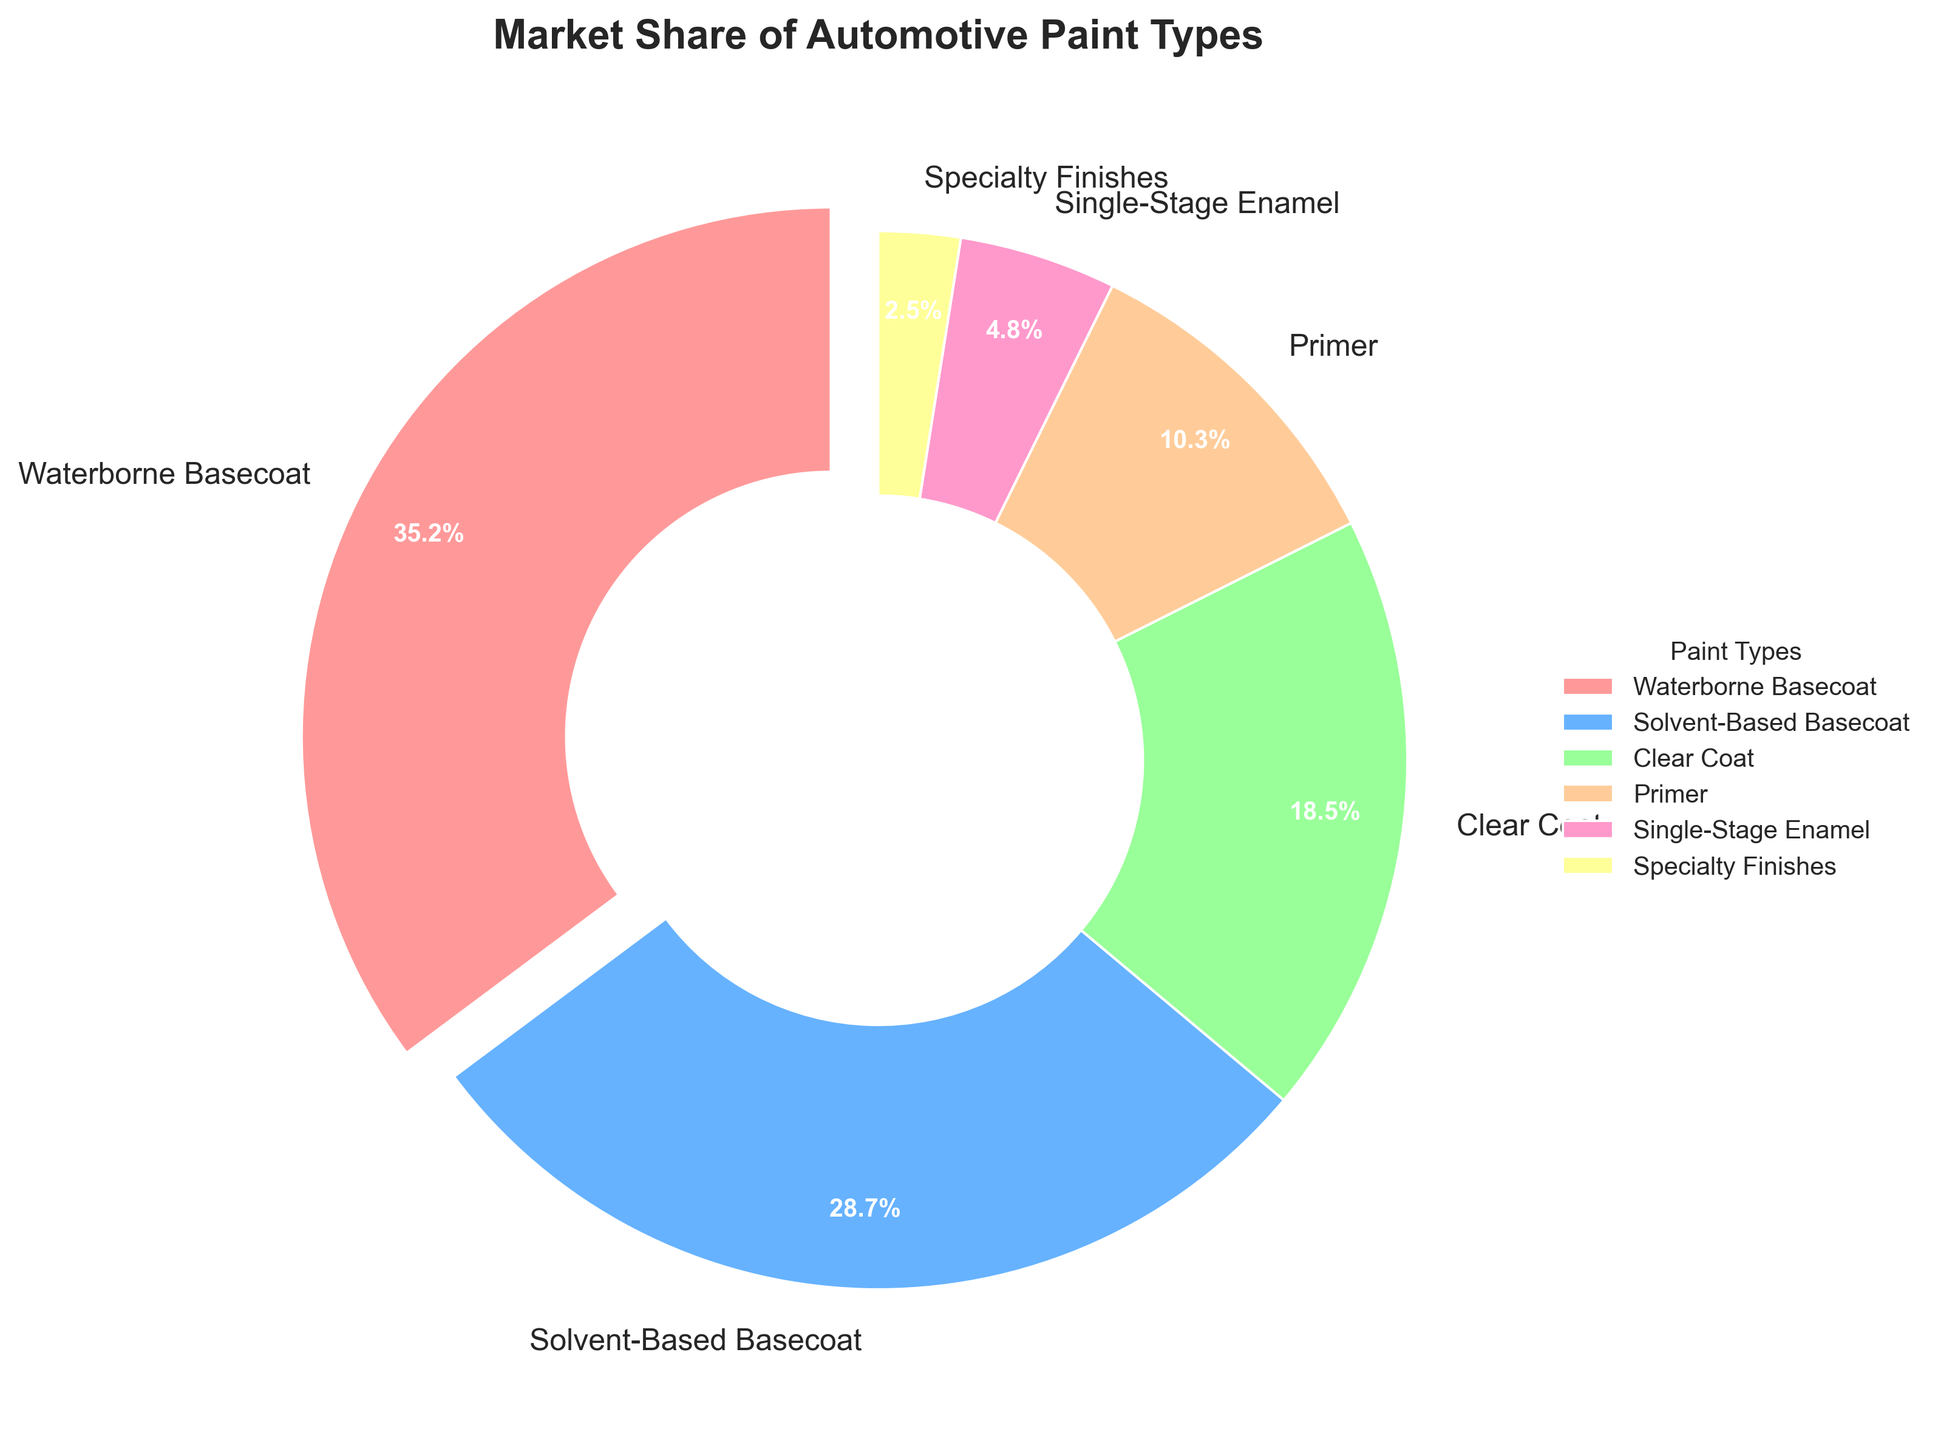What percentage of the market is occupied by Waterborne Basecoat and Solvent-Based Basecoat combined? Add the market share percentages for Waterborne Basecoat (35.2%) and Solvent-Based Basecoat (28.7%). The sum is 35.2 + 28.7 = 63.9%.
Answer: 63.9% Which paint type has the smallest market share? The smallest segment in the pie chart is labeled with a market share of 2.5%, which corresponds to Specialty Finishes.
Answer: Specialty Finishes What is the difference in market share between Clear Coat and Primer? Subtract the market share percentage of Primer (10.3%) from that of Clear Coat (18.5%). The difference is 18.5 - 10.3 = 8.2%.
Answer: 8.2% How much larger is the market share of Waterborne Basecoat compared to Single-Stage Enamel? Subtract the market share percentage of Single-Stage Enamel (4.8%) from that of Waterborne Basecoat (35.2%). The difference is 35.2 - 4.8 = 30.4%.
Answer: 30.4% Which paint type represented by a section on the pie chart is positioned near the 3 o'clock position? The segment starting from the very top (12 o'clock) and moving clockwise to the right position corresponds to the Waterborne Basecoat with a 35.2% market share, which is near the 3 o'clock position.
Answer: Waterborne Basecoat What is the average market share of Clear Coat and Primer? Add the market share percentages for Clear Coat (18.5%) and Primer (10.3%), then divide by 2. The average is (18.5 + 10.3) / 2 = 14.4%.
Answer: 14.4% Which color segment represents Solvent-Based Basecoat? Solvent-Based Basecoat is labeled in blue in the pie chart.
Answer: Blue Which paint types together cover more than 50% of the market? Combining Waterborne Basecoat (35.2%) and Solvent-Based Basecoat (28.7%) results in 63.9%, which is more than 50%.
Answer: Waterborne Basecoat and Solvent-Based Basecoat What fraction of the market share does Primer and Single-Stage Enamel together occupy? Add the market share percentages for Primer (10.3%) and Single-Stage Enamel (4.8%). The sum is 10.3 + 4.8 = 15.1%, which translates to the fraction 15.1/100 = 0.151.
Answer: 0.151 What is the sum of the market shares of all paint types except Waterborne Basecoat? Subtract the market share percentage of Waterborne Basecoat (35.2%) from 100%. The remaining market share is 100 - 35.2 = 64.8%.
Answer: 64.8% 